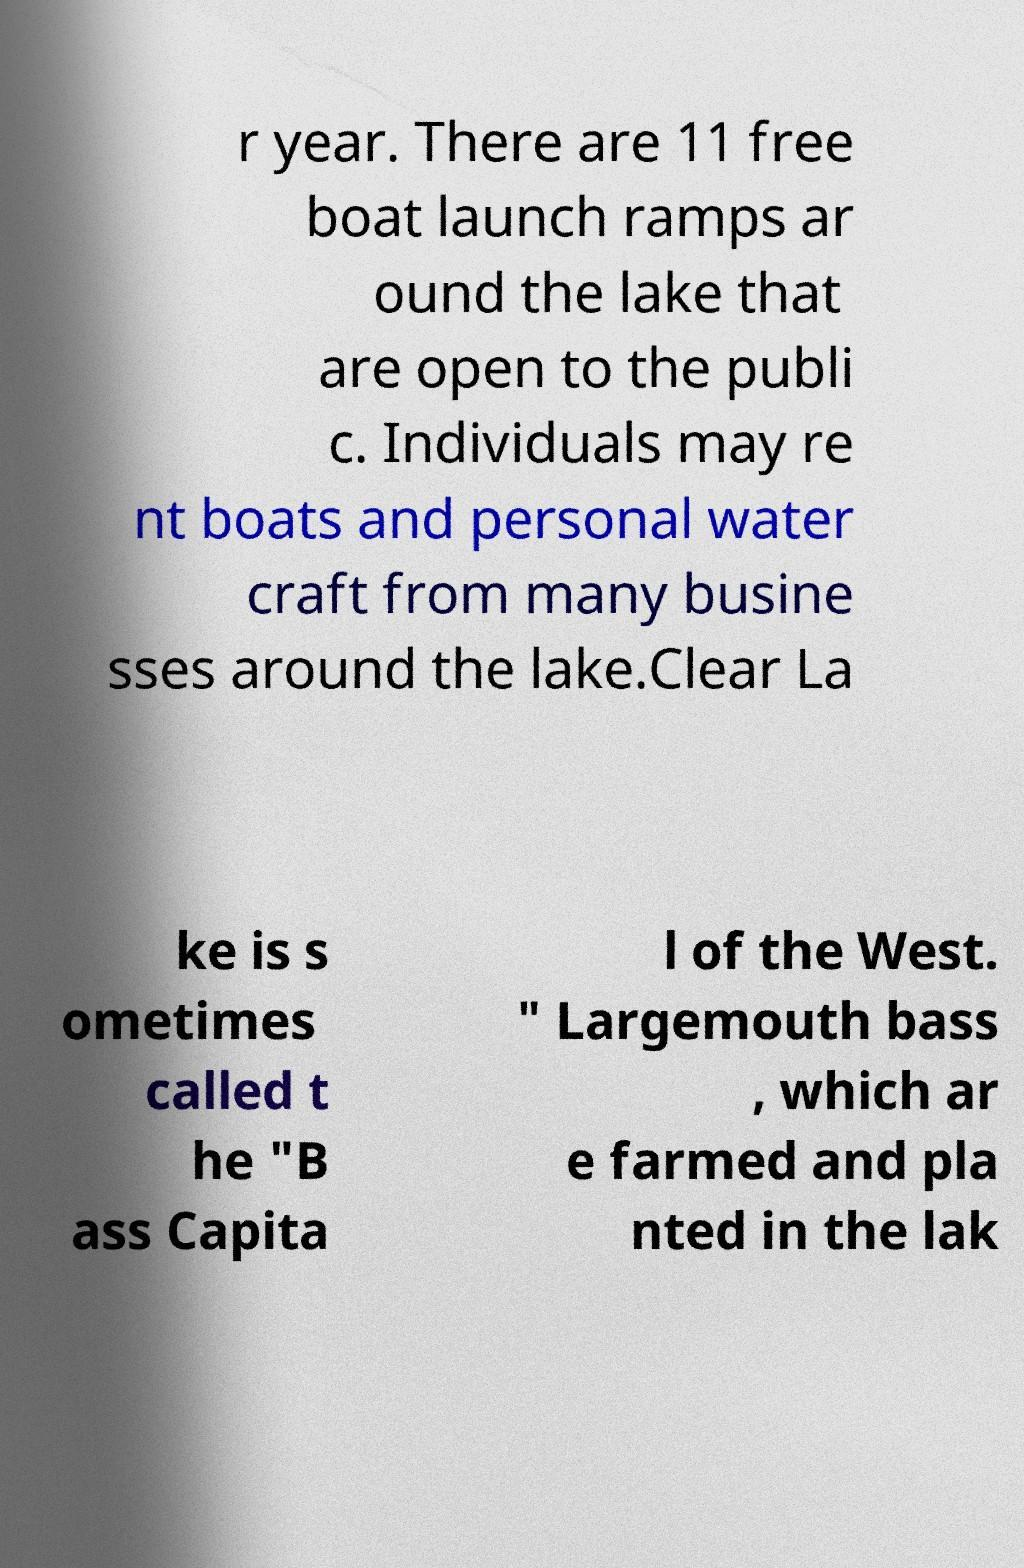Can you accurately transcribe the text from the provided image for me? r year. There are 11 free boat launch ramps ar ound the lake that are open to the publi c. Individuals may re nt boats and personal water craft from many busine sses around the lake.Clear La ke is s ometimes called t he "B ass Capita l of the West. " Largemouth bass , which ar e farmed and pla nted in the lak 